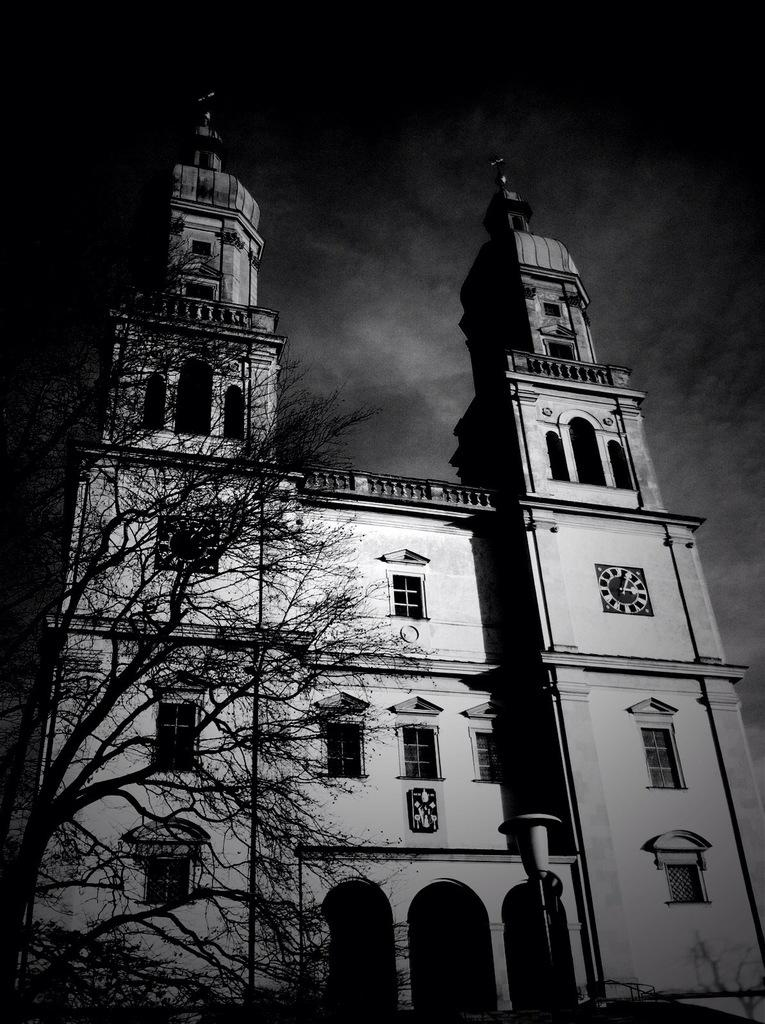What is the color scheme of the image? The image is in black and white. What is the main subject in the center of the image? There is a castle in the center of the image. What is located in front of the castle? There is a tree before the castle. How many flocks of birds can be seen flying around the castle in the image? There are no flocks of birds visible in the image; it is in black and white and features a castle and a tree. What type of wheel is attached to the castle in the image? There is no wheel present in the image; it features a castle and a tree in a black and white color scheme. 